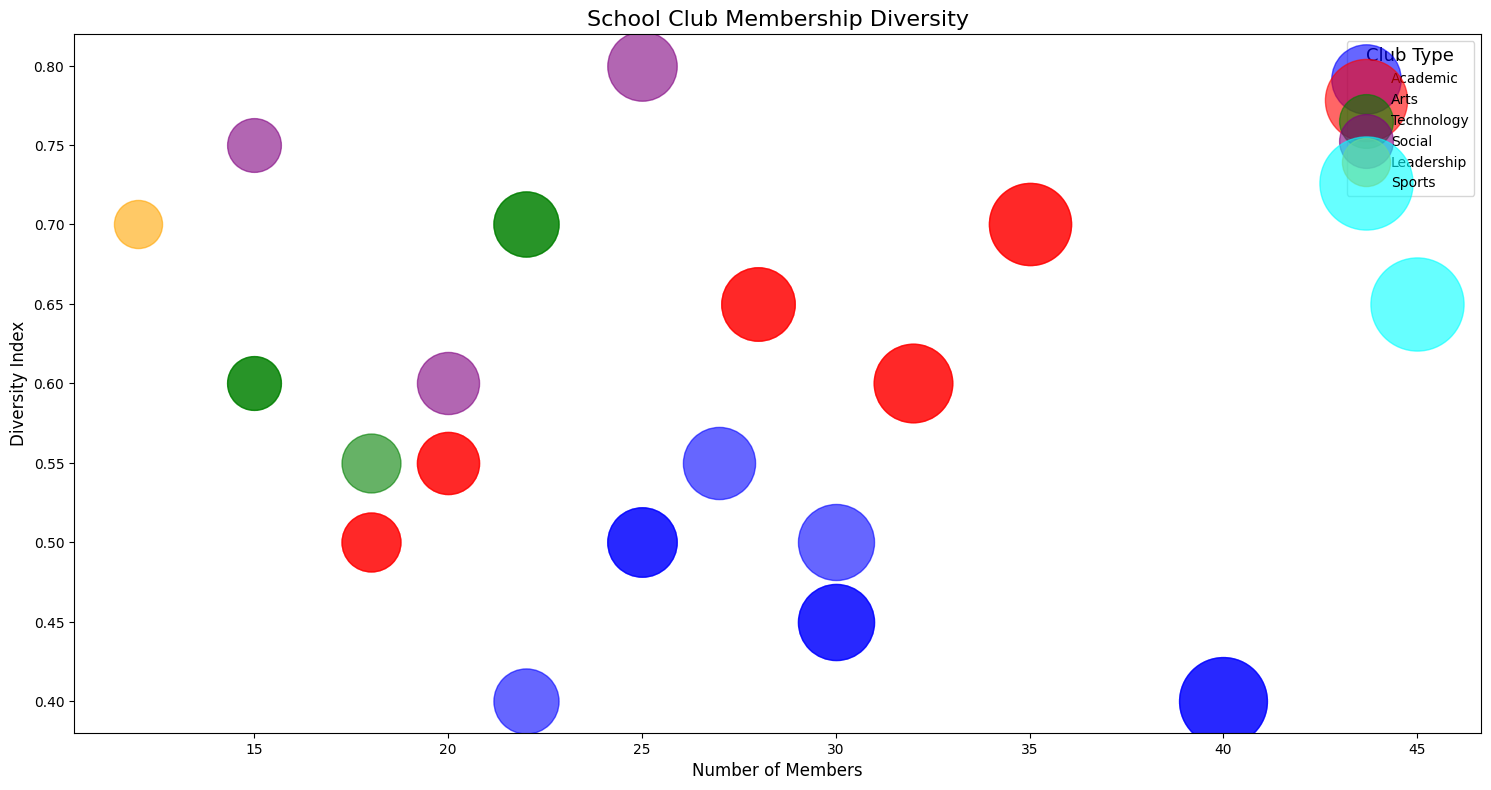Which club has the highest Diversity Index? The club with the highest Diversity Index is identified by the highest position on the y-axis.
Answer: Cultural Exchange Club Which club has the most members? The club with the most members will have the largest bubble.
Answer: Athletics Club Which types of clubs have the same highest Diversity Index value? By comparing the colors representing club types at the highest point on the y-axis, we find that both 'Social' (purple - Environmental Club) and 'Leadership' (orange - Student Government) categories reach the Diversity Index of 0.8 and 0.7 respectively.
Answer: Social and Leadership Which club among Academic type clubs has the lowest Diversity Index? Within the 'Academic' type (blue bubbles), the club with the lowest y-axis value is the Math Club.
Answer: Math Club Which club within the Technology type has more members, Robotics Club or Coding Club? By comparing the bubble sizes of 'Technology' type (green bubbles) clubs, we see that the Coding Club has more members than the Robotics Club.
Answer: Coding Club What is the average number of members in clubs of the Technology type? Add the number of members of all clubs in the Technology type and divide by the number of such clubs: (15 + 22 + 18) / 3 = 55 / 3 = 18.3
Answer: 18.3 Compare the Diversity Index of Drama Club with that of Coding Club. Which is higher? Look at the heights of the red bubble for Drama Club and the green bubble for Coding Club. Drama Club has a Diversity Index of 0.7 while Coding Club also has 0.7.
Answer: Equal Which has a larger Diversity Index, the Athletics Club or the Math Club? By comparing their positions on the y-axis, the Athletics Club (cyan bubble) has a higher Diversity Index (0.65) than the Math Club (blue bubble with 0.4).
Answer: Athletics Club Which type of clubs generally seem to have a higher Diversity Index? Observe the distribution of bubble heights by colors. 'Social' (purple) clubs have higher Diversity Indices on average compared to other types.
Answer: Social type What is the total number of members in all 'Arts' type clubs? Sum the number of members for each club in the Arts type: 35 (Drama) + 20 (Music Band) + 28 (Dance) + 18 (Photography) + 32 (Art) = 133
Answer: 133 